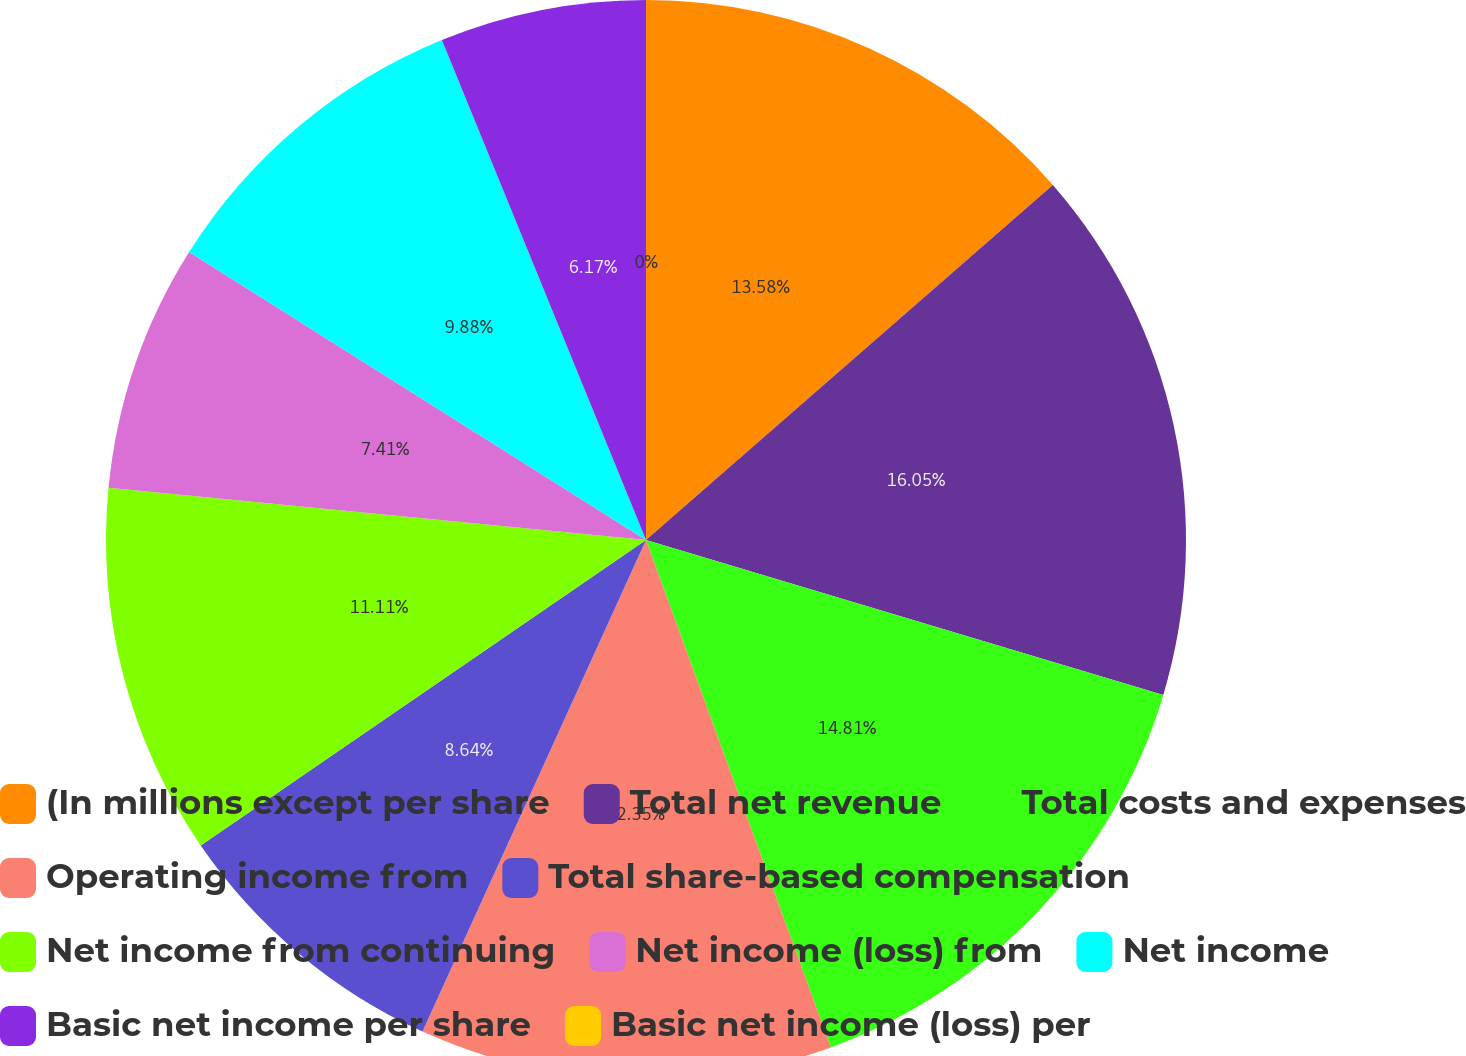<chart> <loc_0><loc_0><loc_500><loc_500><pie_chart><fcel>(In millions except per share<fcel>Total net revenue<fcel>Total costs and expenses<fcel>Operating income from<fcel>Total share-based compensation<fcel>Net income from continuing<fcel>Net income (loss) from<fcel>Net income<fcel>Basic net income per share<fcel>Basic net income (loss) per<nl><fcel>13.58%<fcel>16.05%<fcel>14.81%<fcel>12.35%<fcel>8.64%<fcel>11.11%<fcel>7.41%<fcel>9.88%<fcel>6.17%<fcel>0.0%<nl></chart> 